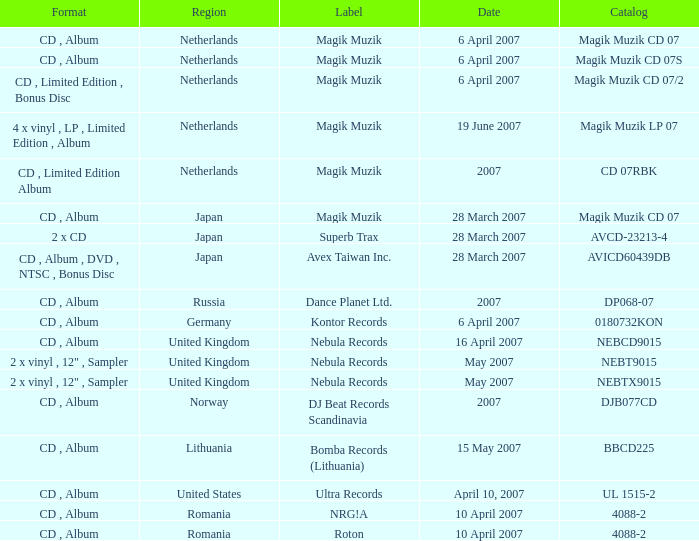Which label released the catalog Magik Muzik CD 07 on 28 March 2007? Magik Muzik. 